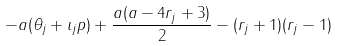Convert formula to latex. <formula><loc_0><loc_0><loc_500><loc_500>- a ( \theta _ { j } + \iota _ { j } p ) + \frac { a ( a - 4 r _ { j } + 3 ) } { 2 } - ( r _ { j } + 1 ) ( r _ { j } - 1 )</formula> 